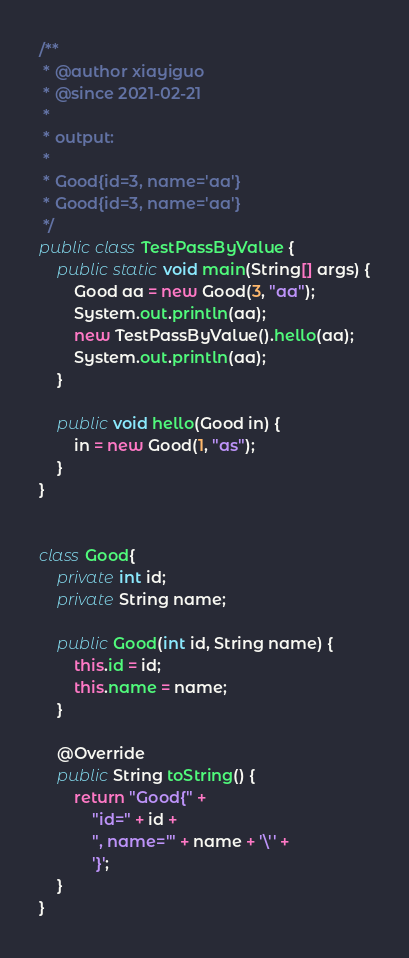<code> <loc_0><loc_0><loc_500><loc_500><_Java_>/**
 * @author xiayiguo
 * @since 2021-02-21
 *
 * output:
 *
 * Good{id=3, name='aa'}
 * Good{id=3, name='aa'}
 */
public class TestPassByValue {
    public static void main(String[] args) {
        Good aa = new Good(3, "aa");
        System.out.println(aa);
        new TestPassByValue().hello(aa);
        System.out.println(aa);
    }

    public void hello(Good in) {
        in = new Good(1, "as");
    }
}


class Good{
    private int id;
    private String name;

    public Good(int id, String name) {
        this.id = id;
        this.name = name;
    }

    @Override
    public String toString() {
        return "Good{" +
            "id=" + id +
            ", name='" + name + '\'' +
            '}';
    }
}</code> 